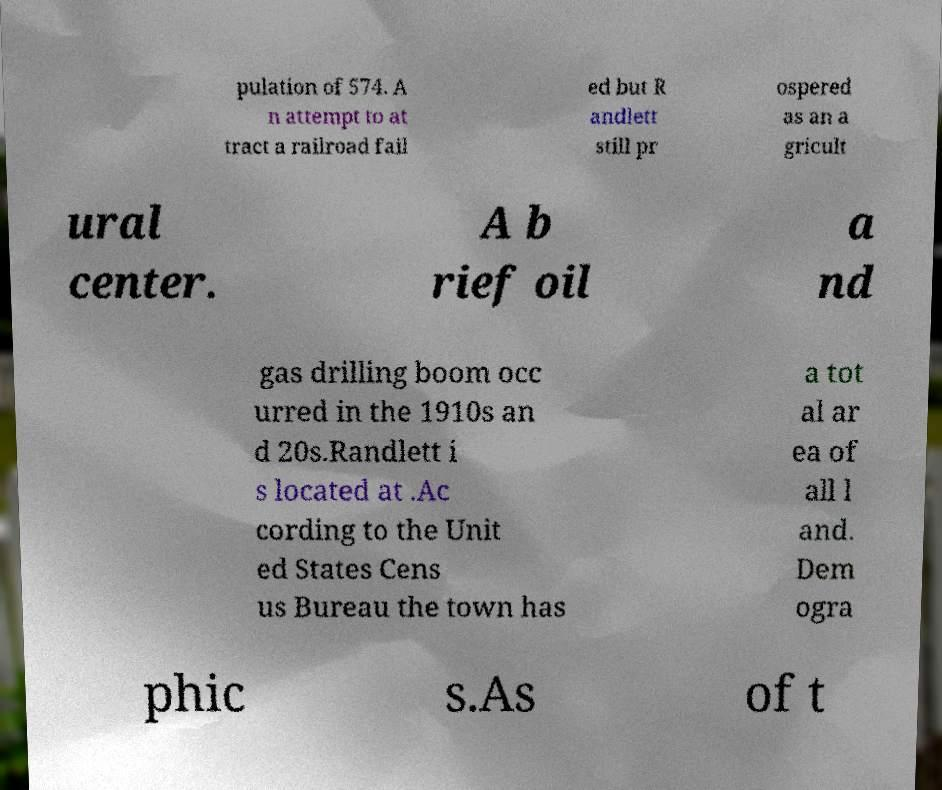I need the written content from this picture converted into text. Can you do that? pulation of 574. A n attempt to at tract a railroad fail ed but R andlett still pr ospered as an a gricult ural center. A b rief oil a nd gas drilling boom occ urred in the 1910s an d 20s.Randlett i s located at .Ac cording to the Unit ed States Cens us Bureau the town has a tot al ar ea of all l and. Dem ogra phic s.As of t 